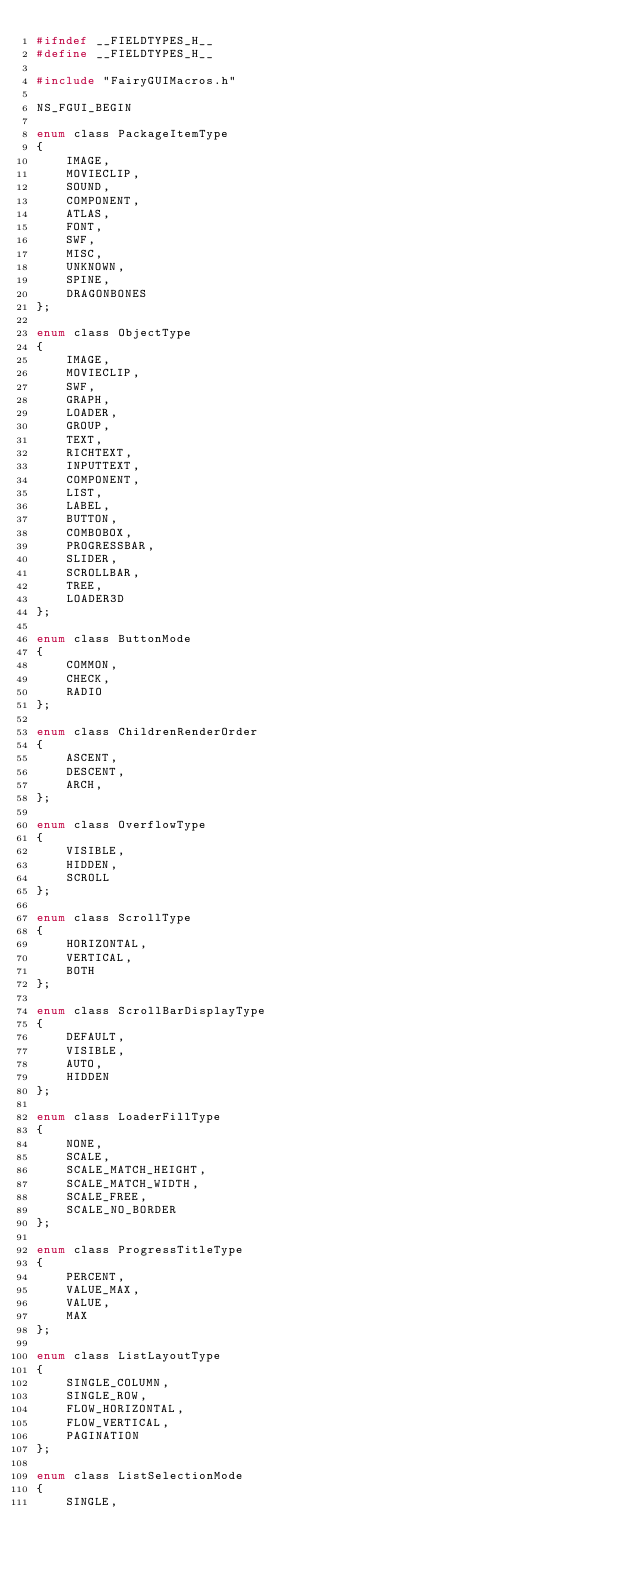Convert code to text. <code><loc_0><loc_0><loc_500><loc_500><_C_>#ifndef __FIELDTYPES_H__
#define __FIELDTYPES_H__

#include "FairyGUIMacros.h"

NS_FGUI_BEGIN

enum class PackageItemType
{
    IMAGE,
    MOVIECLIP,
    SOUND,
    COMPONENT,
    ATLAS,
    FONT,
    SWF,
    MISC,
    UNKNOWN,
    SPINE,
    DRAGONBONES
};

enum class ObjectType
{
    IMAGE,
    MOVIECLIP,
    SWF,
    GRAPH,
    LOADER,
    GROUP,
    TEXT,
    RICHTEXT,
    INPUTTEXT,
    COMPONENT,
    LIST,
    LABEL,
    BUTTON,
    COMBOBOX,
    PROGRESSBAR,
    SLIDER,
    SCROLLBAR,
    TREE,
    LOADER3D
};

enum class ButtonMode
{
    COMMON,
    CHECK,
    RADIO
};

enum class ChildrenRenderOrder
{
    ASCENT,
    DESCENT,
    ARCH,
};

enum class OverflowType
{
    VISIBLE,
    HIDDEN,
    SCROLL
};

enum class ScrollType
{
    HORIZONTAL,
    VERTICAL,
    BOTH
};

enum class ScrollBarDisplayType
{
    DEFAULT,
    VISIBLE,
    AUTO,
    HIDDEN
};

enum class LoaderFillType
{
    NONE,
    SCALE,
    SCALE_MATCH_HEIGHT,
    SCALE_MATCH_WIDTH,
    SCALE_FREE,
    SCALE_NO_BORDER
};

enum class ProgressTitleType
{
    PERCENT,
    VALUE_MAX,
    VALUE,
    MAX
};

enum class ListLayoutType
{
    SINGLE_COLUMN,
    SINGLE_ROW,
    FLOW_HORIZONTAL,
    FLOW_VERTICAL,
    PAGINATION
};

enum class ListSelectionMode
{
    SINGLE,</code> 